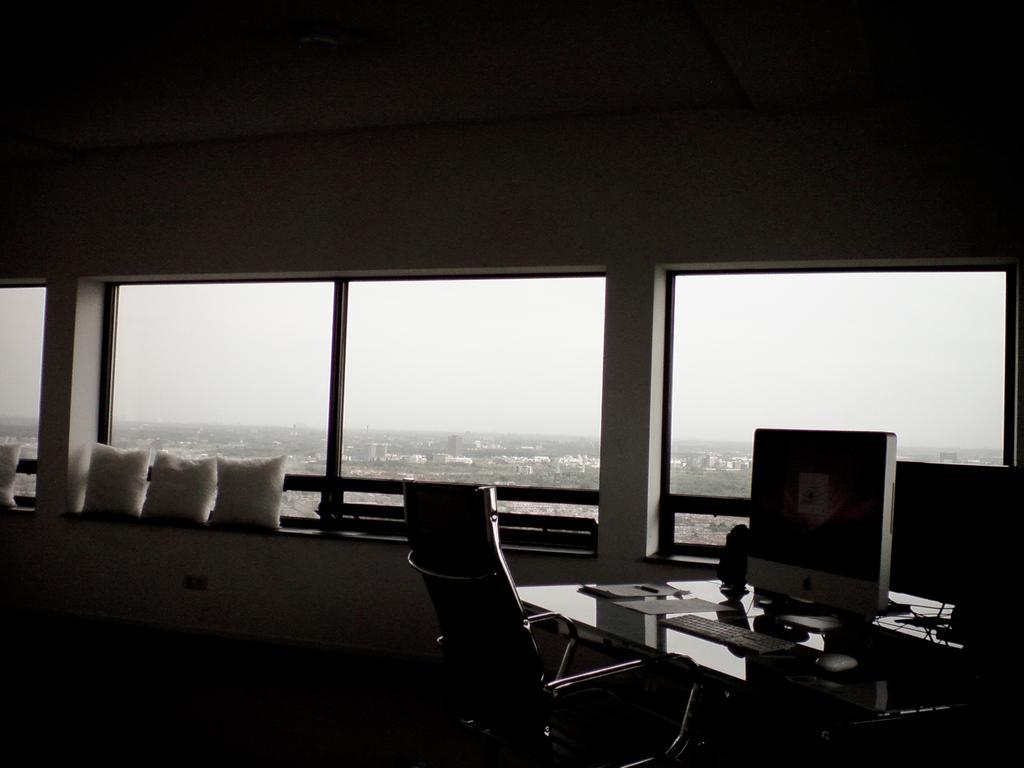In one or two sentences, can you explain what this image depicts? This image is taken inside a room. In the background of the image there are glass windows. To the right side of the image there is a table on which there is a monitor, keyboard and other objects. In the center of the image there is a chair. At the top of the image there is ceiling. 